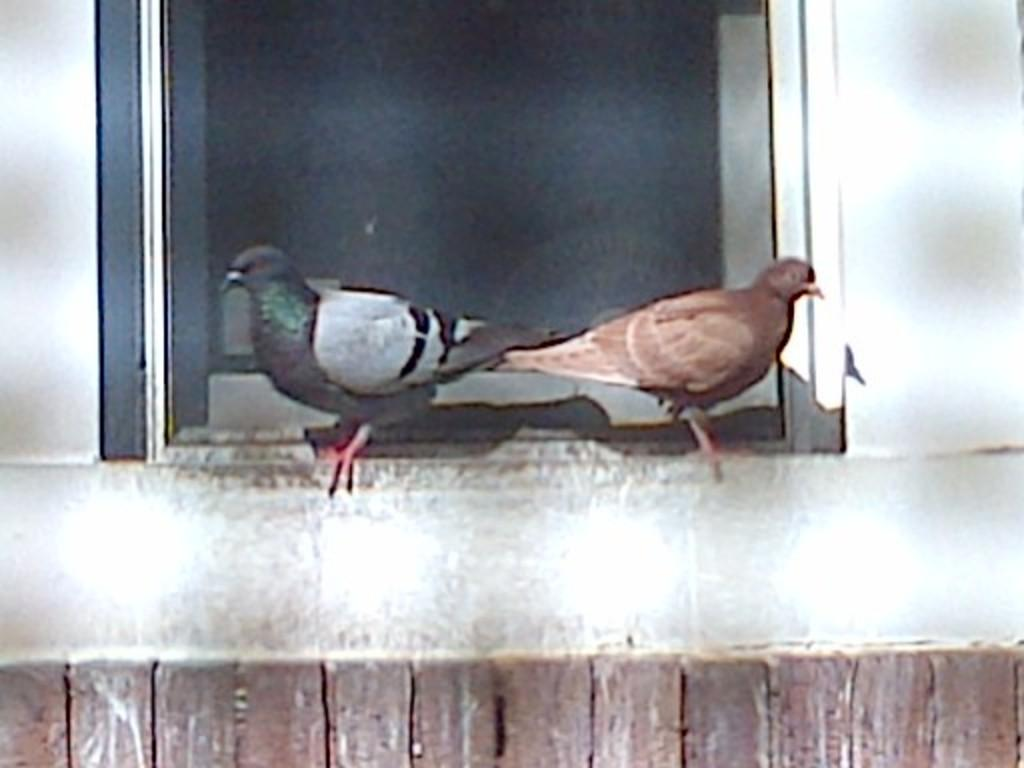How many birds are in the image? There are two birds in the image. What colors can be seen on the birds? The birds are in black, ash, and brown colors. Where are the birds located in the image? The birds are on the window of a building. Is there a cave in the image where the birds are exchanging information? There is no cave present in the image, and the birds are not shown exchanging information. 